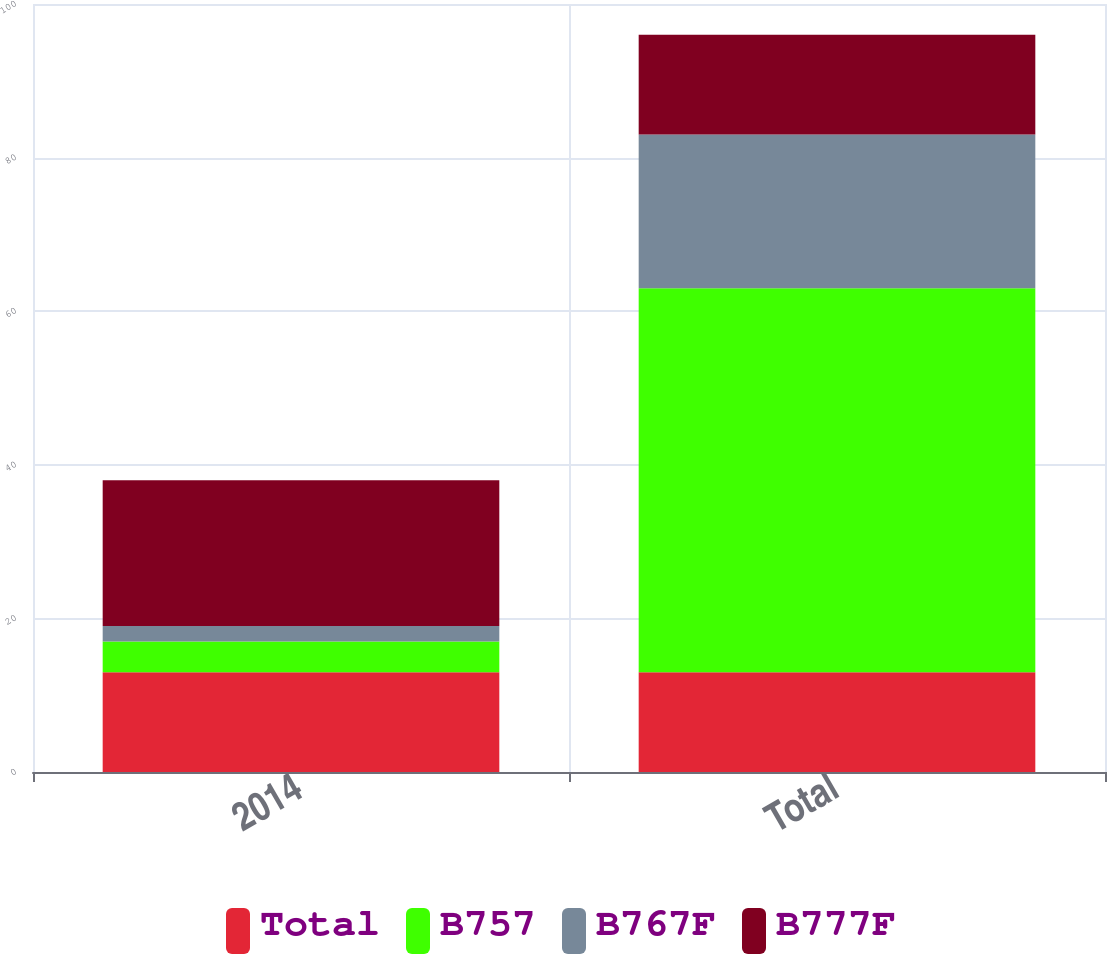Convert chart. <chart><loc_0><loc_0><loc_500><loc_500><stacked_bar_chart><ecel><fcel>2014<fcel>Total<nl><fcel>Total<fcel>13<fcel>13<nl><fcel>B757<fcel>4<fcel>50<nl><fcel>B767F<fcel>2<fcel>20<nl><fcel>B777F<fcel>19<fcel>13<nl></chart> 